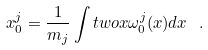<formula> <loc_0><loc_0><loc_500><loc_500>x ^ { j } _ { 0 } = \frac { 1 } { m _ { j } } \int t w o x \omega ^ { j } _ { 0 } ( x ) d x \ .</formula> 